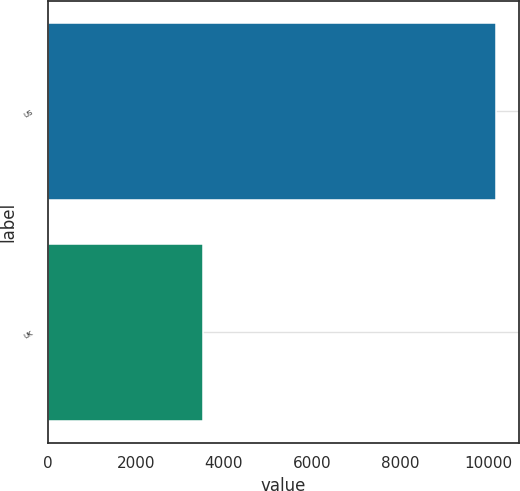<chart> <loc_0><loc_0><loc_500><loc_500><bar_chart><fcel>US<fcel>UK<nl><fcel>10181<fcel>3517<nl></chart> 